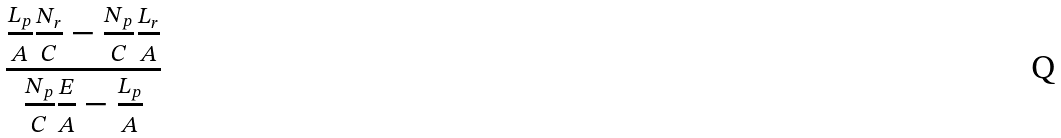Convert formula to latex. <formula><loc_0><loc_0><loc_500><loc_500>\frac { \frac { L _ { p } } { A } \frac { N _ { r } } { C } - \frac { N _ { p } } { C } \frac { L _ { r } } { A } } { \frac { N _ { p } } { C } \frac { E } { A } - \frac { L _ { p } } { A } }</formula> 